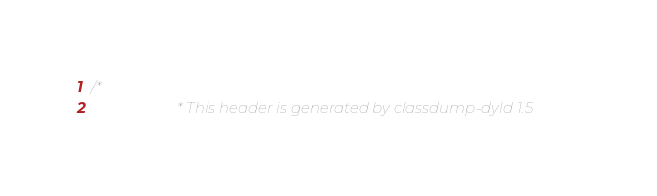<code> <loc_0><loc_0><loc_500><loc_500><_C_>/*
                       * This header is generated by classdump-dyld 1.5</code> 